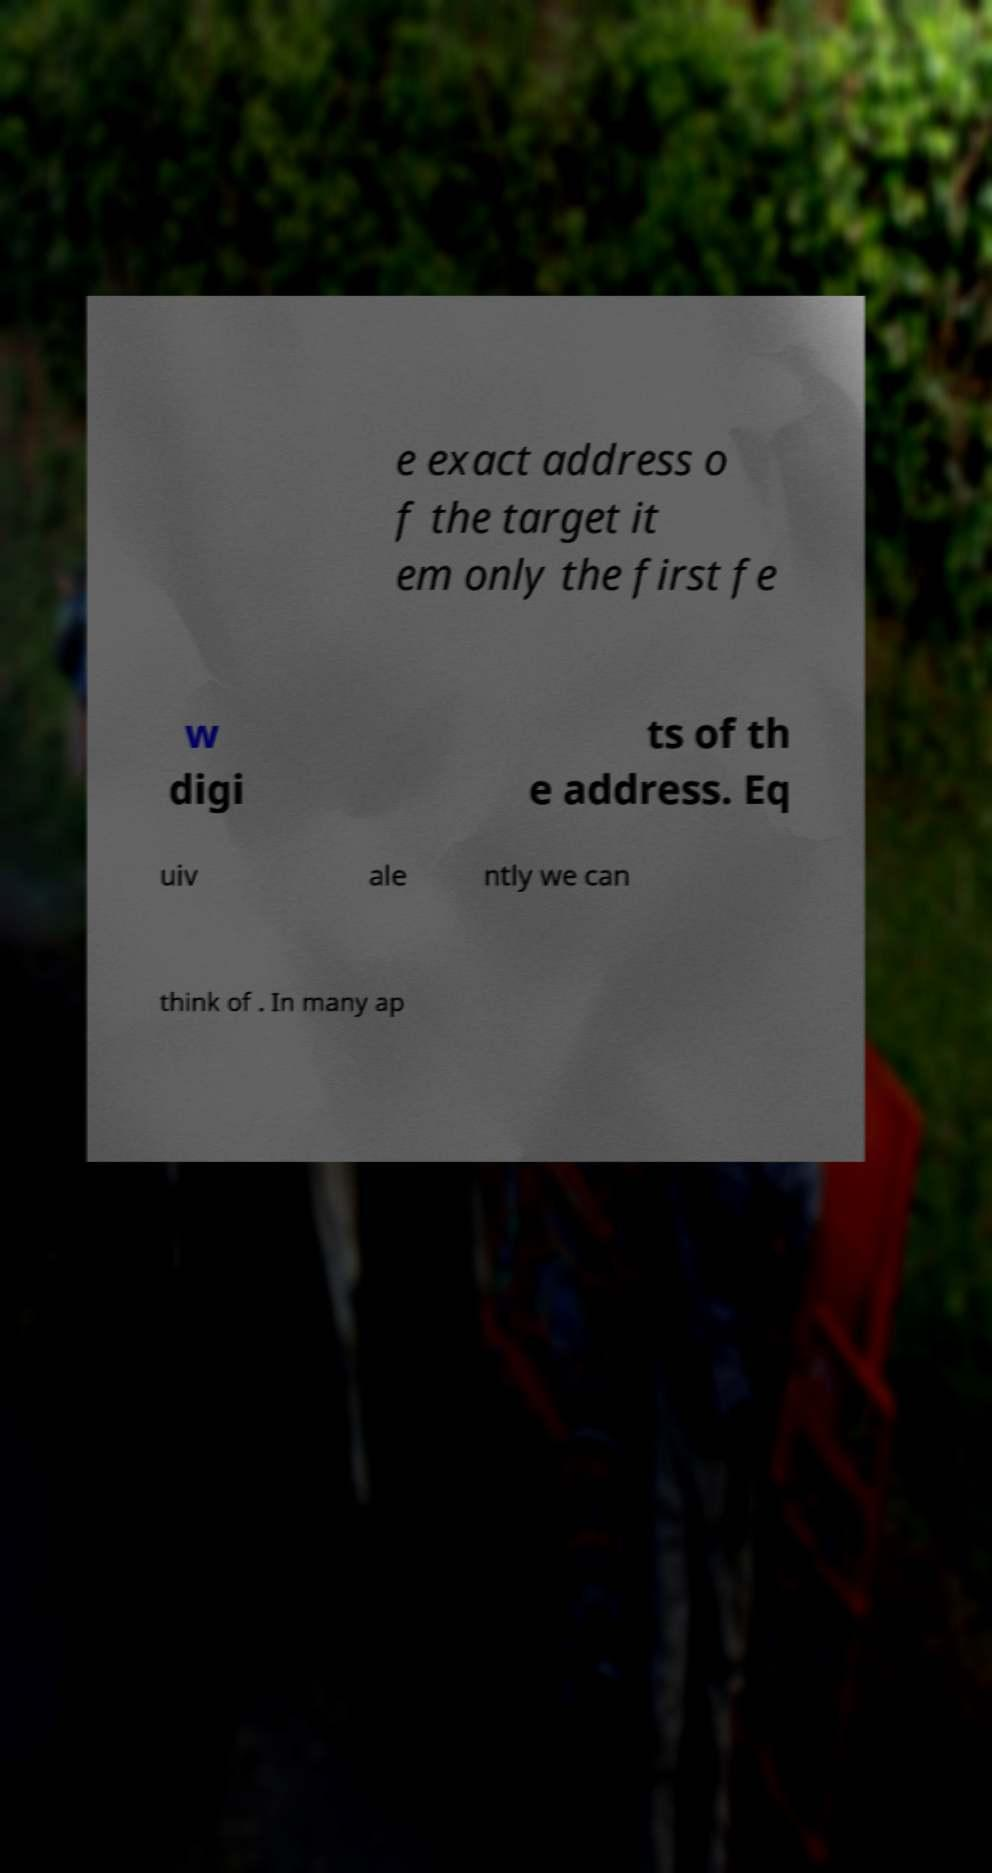I need the written content from this picture converted into text. Can you do that? e exact address o f the target it em only the first fe w digi ts of th e address. Eq uiv ale ntly we can think of . In many ap 